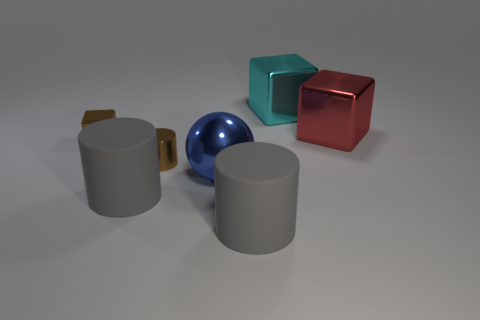What might be the purpose of the objects in the image? The objects in the image appear to be simple geometric shapes, potentially used for a visual composition exercise in an art or design context, or as digital rendering practice in a 3D modeling software. 